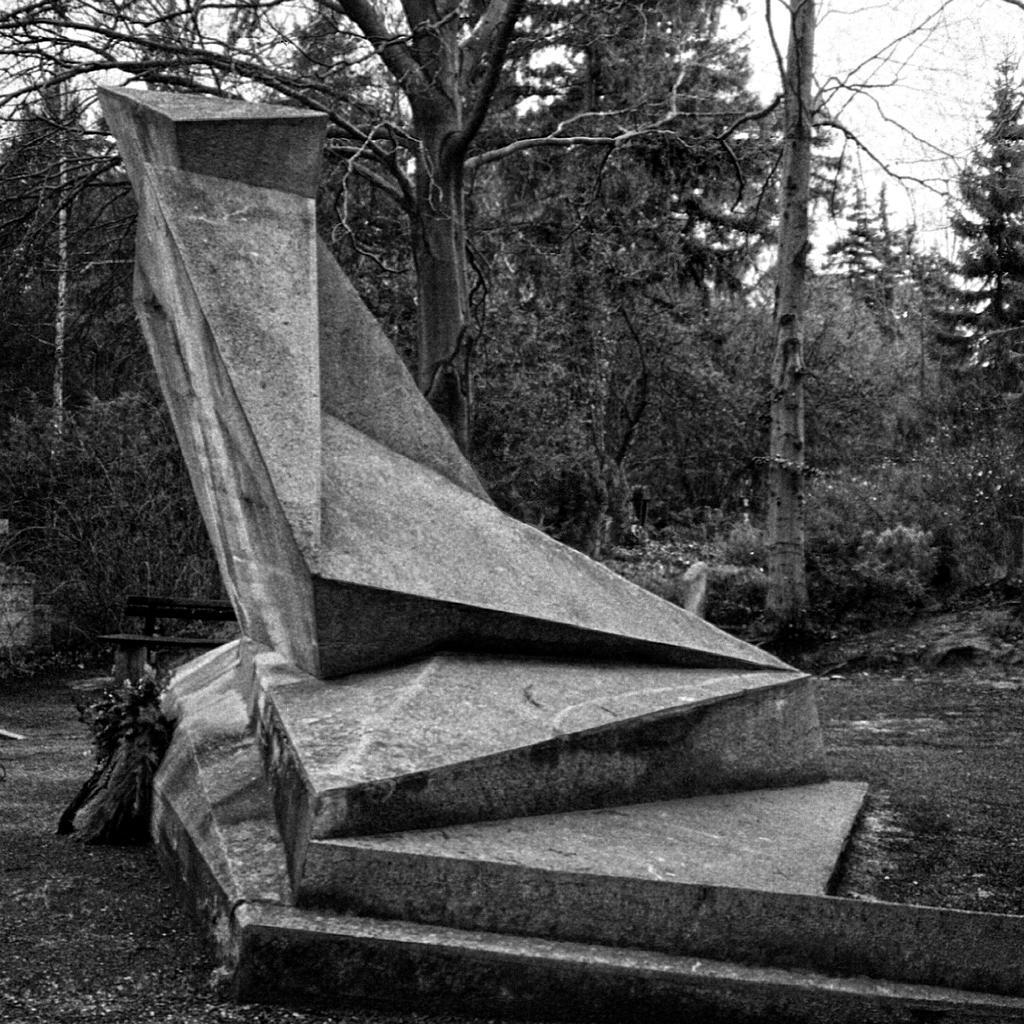Please provide a concise description of this image. In this image we can see a statue. On the backside we can see a group of trees, a bench, the bark of the trees, a pole and the sky. 